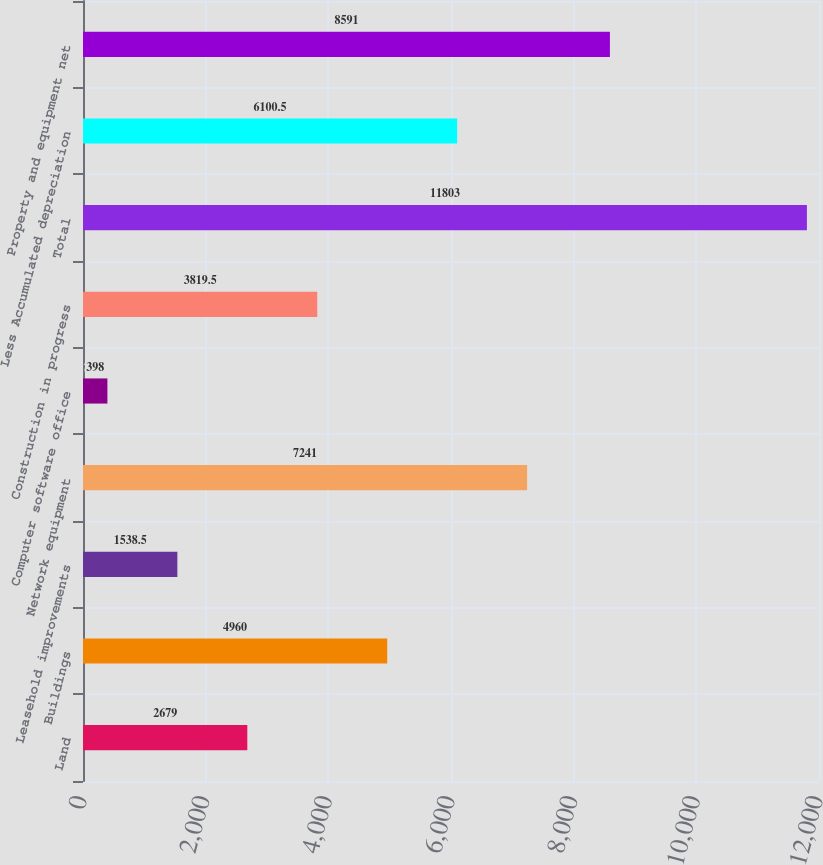Convert chart. <chart><loc_0><loc_0><loc_500><loc_500><bar_chart><fcel>Land<fcel>Buildings<fcel>Leasehold improvements<fcel>Network equipment<fcel>Computer software office<fcel>Construction in progress<fcel>Total<fcel>Less Accumulated depreciation<fcel>Property and equipment net<nl><fcel>2679<fcel>4960<fcel>1538.5<fcel>7241<fcel>398<fcel>3819.5<fcel>11803<fcel>6100.5<fcel>8591<nl></chart> 